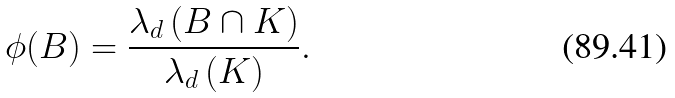<formula> <loc_0><loc_0><loc_500><loc_500>\phi ( B ) = \frac { \lambda _ { d } \left ( B \cap K \right ) } { \lambda _ { d } \left ( K \right ) } .</formula> 